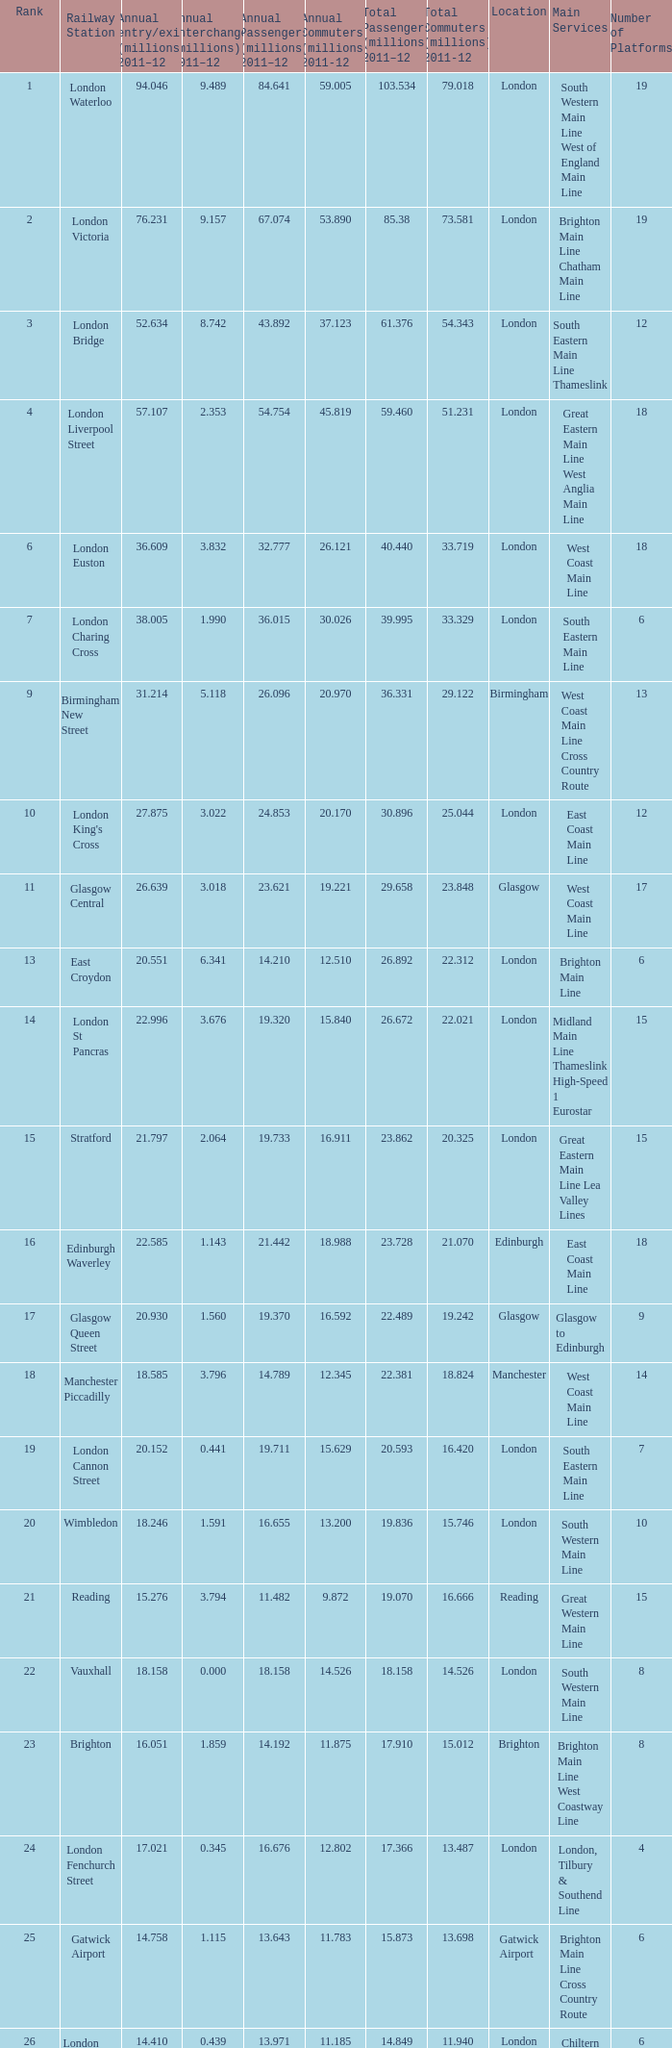What is the lowest rank of Gatwick Airport?  25.0. 